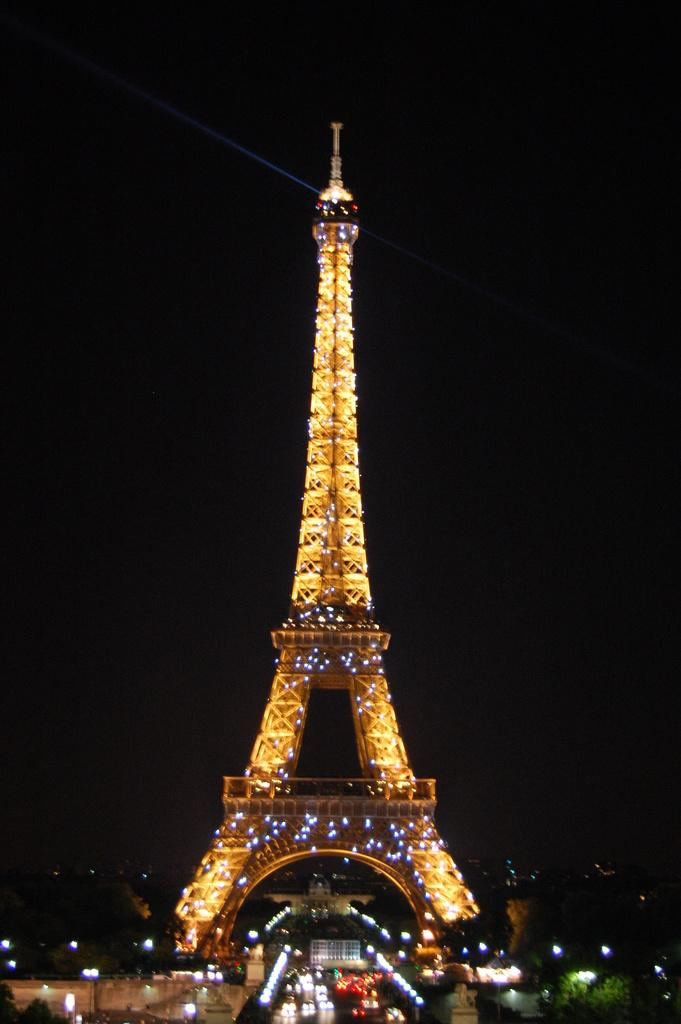What is the dominant feature in the image? There are many lights in the image. What type of vegetation can be seen in the image? There are few trees in the image. What structure is present in the image? There is a tower in the image. What color is the background of the image? The background of the image is black. What type of sign can be seen hanging from the tower in the image? There is no sign present in the image; only lights, trees, and a tower are visible. Can you spot a snake slithering through the trees in the image? There is no snake present in the image; it only features lights, trees, and a tower. 